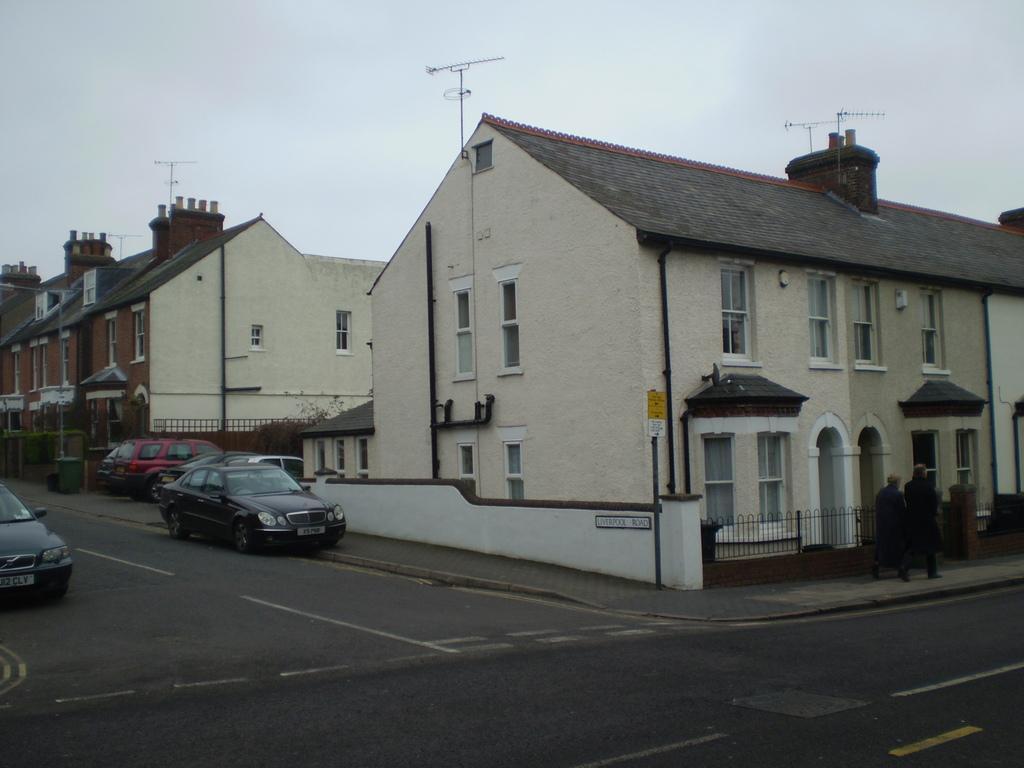Could you give a brief overview of what you see in this image? In this image we can see there are houses and it has antennas on the top, in front of it there is a road which consists of cars, on the right side of the image there are two people, behind them there are fences. 